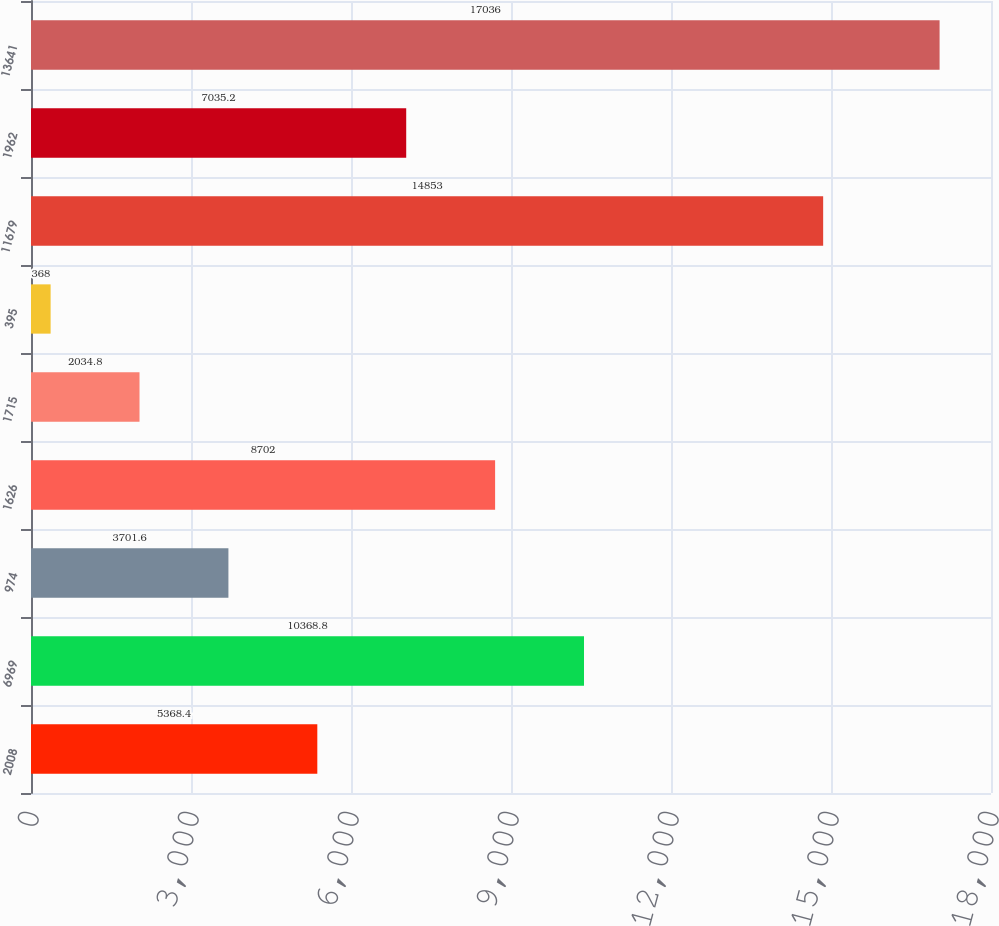<chart> <loc_0><loc_0><loc_500><loc_500><bar_chart><fcel>2008<fcel>6969<fcel>974<fcel>1626<fcel>1715<fcel>395<fcel>11679<fcel>1962<fcel>13641<nl><fcel>5368.4<fcel>10368.8<fcel>3701.6<fcel>8702<fcel>2034.8<fcel>368<fcel>14853<fcel>7035.2<fcel>17036<nl></chart> 